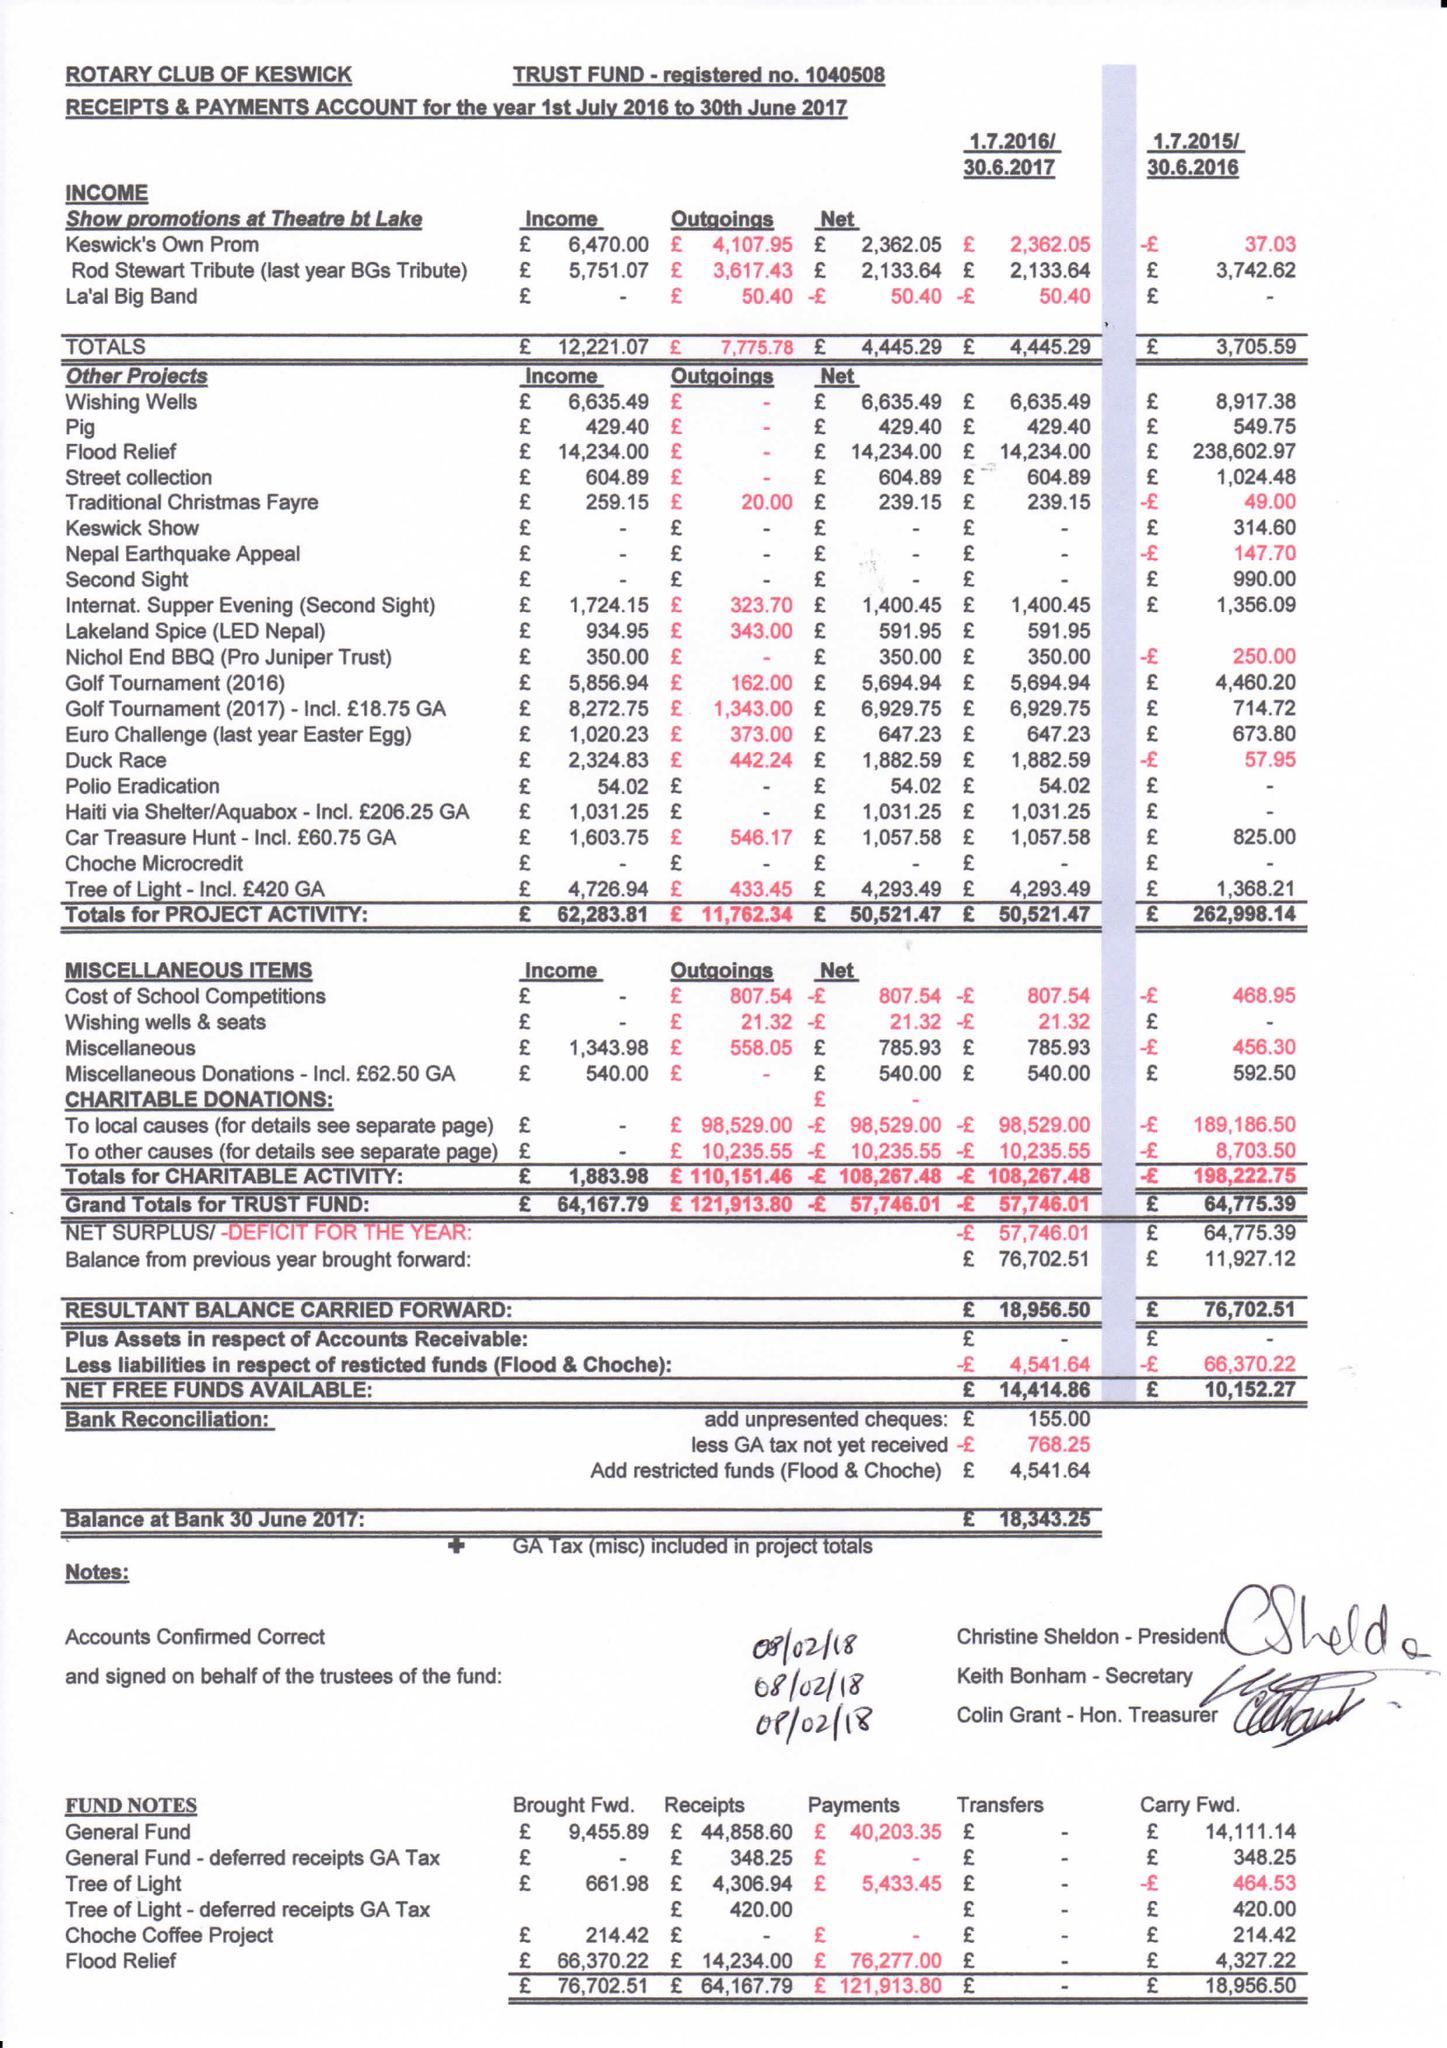What is the value for the address__street_line?
Answer the question using a single word or phrase. None 